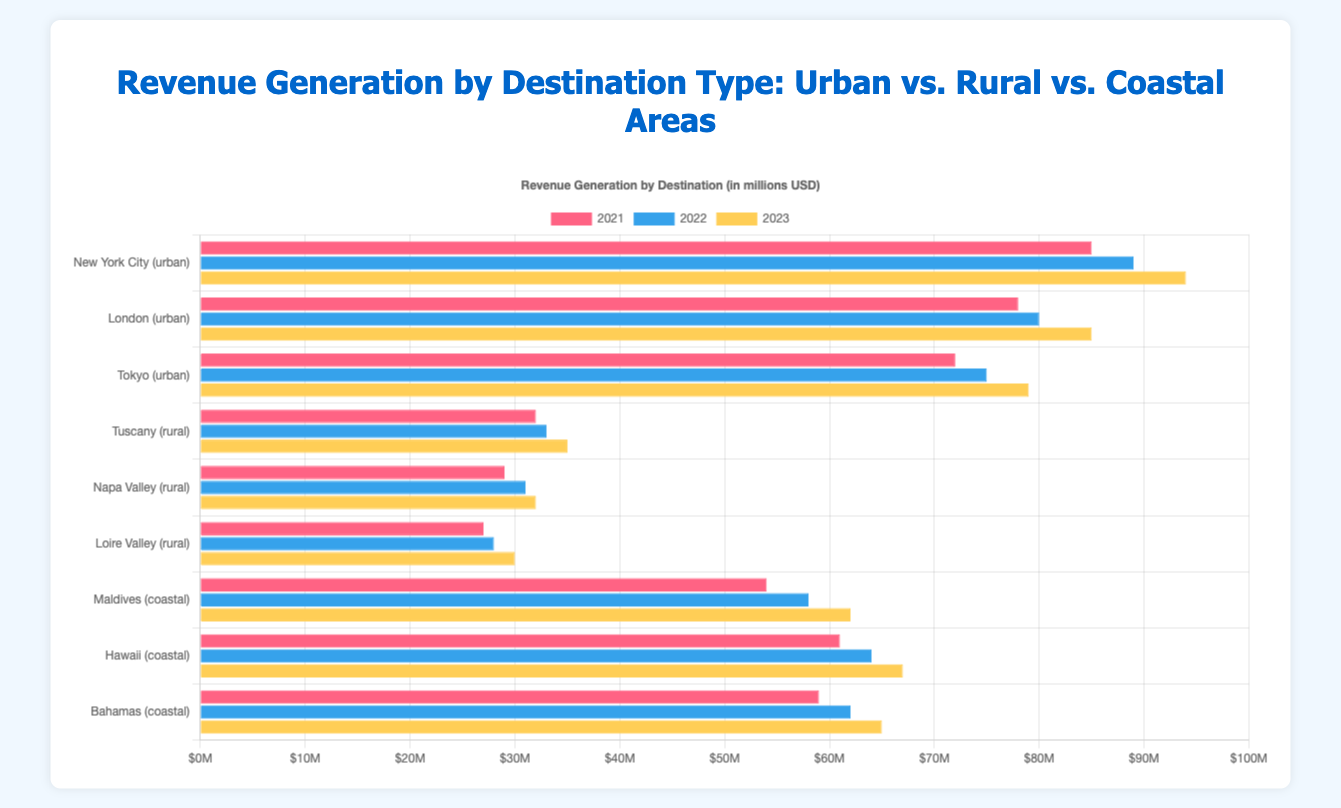What was the total revenue generated by all destinations in 2022? To find the total revenue for all destinations in 2022, sum up the revenues for urban, rural, and coastal areas for that year. Urban: 89000000 + 80000000 + 75000000 = 244000000. Rural: 33000000 + 31000000 + 28000000 = 92000000. Coastal: 58000000 + 64000000 + 62000000 = 184000000. Total revenue = 244000000 + 92000000 + 184000000 = 520000000.
Answer: 520,000,000 Which destination had the highest revenue in 2021? Identify the peak revenue value in 2021 by comparing the first segment of all grouped bars. New York City had the highest revenue among all destinations in 2021 with 85,000,000 USD.
Answer: New York City What was the revenue difference between the Maldives and Tuscany in 2023? Calculate the revenue for Maldives and Tuscany in 2023 respectively, then find the difference. Maldives: 62000000. Tuscany: 35000000. Difference = 62000000 - 35000000 = 27000000.
Answer: 27,000,000 Which type of destination saw the most significant increase in revenue from 2022 to 2023? Compare the total revenue increments for each destination type from 2022 to 2023. Urban: (94000000 - 89000000) + (85000000 - 80000000) + (79000000 - 75000000) = 15000000 + 5000000 + 4000000 = 24000000. Rural: (35000000 - 33000000) + (32000000 - 31000000) + (30000000 - 28000000) = 2000000 + 1000000 + 2000000 = 5000000. Coastal: (62000000 - 58000000) + (67000000 - 64000000) + (65000000 - 62000000) = 4000000 + 3000000 + 3000000 = 10000000.
Answer: Urban What is the average revenue generated by London over the three years? Add the revenues for London in 2021, 2022, and 2023, then divide by the number of years. (78000000 + 80000000 + 85000000) / 3 = 243000000 / 3 = 81000000.
Answer: 81,000,000 Which coastal destination had the lowest revenue in 2023? Compare the 2023 revenues of all coastal destinations to identify the lowest. Maldives: 62000000. Hawaii: 67000000. Bahamas: 65000000. The Maldives had the lowest revenue in 2023.
Answer: Maldives Did any rural destination have a decline in revenue from 2021 to 2023? Compare year-over-year revenue changes for all rural destinations. Tuscany: 32000000 to 33000000 to 35000000 (no decline), Napa Valley: 29000000 to 31000000 to 32000000 (no decline), Loire Valley: 27000000 to 28000000 to 30000000 (no decline). All rural destinations saw an increase.
Answer: No How does the revenue of Tokyo in 2023 compare to the revenue of Hawaii in the same year? Compare the revenue figures of Tokyo and Hawaii in 2023. Tokyo: 79000000. Hawaii: 67000000. Tokyo had higher revenue.
Answer: Tokyo had higher revenue Summarize the trend for urban destinations from 2021 to 2023. Examine the revenue data for all urban destinations across the three years. New York City: 85000000 to 89000000 to 94000000 (increasing), London: 78000000 to 80000000 to 85000000 (increasing), Tokyo: 72000000 to 75000000 to 79000000 (increasing). All urban destinations show an upward trend in revenue.
Answer: Upward trend 